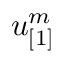Convert formula to latex. <formula><loc_0><loc_0><loc_500><loc_500>u _ { [ 1 ] } ^ { m }</formula> 